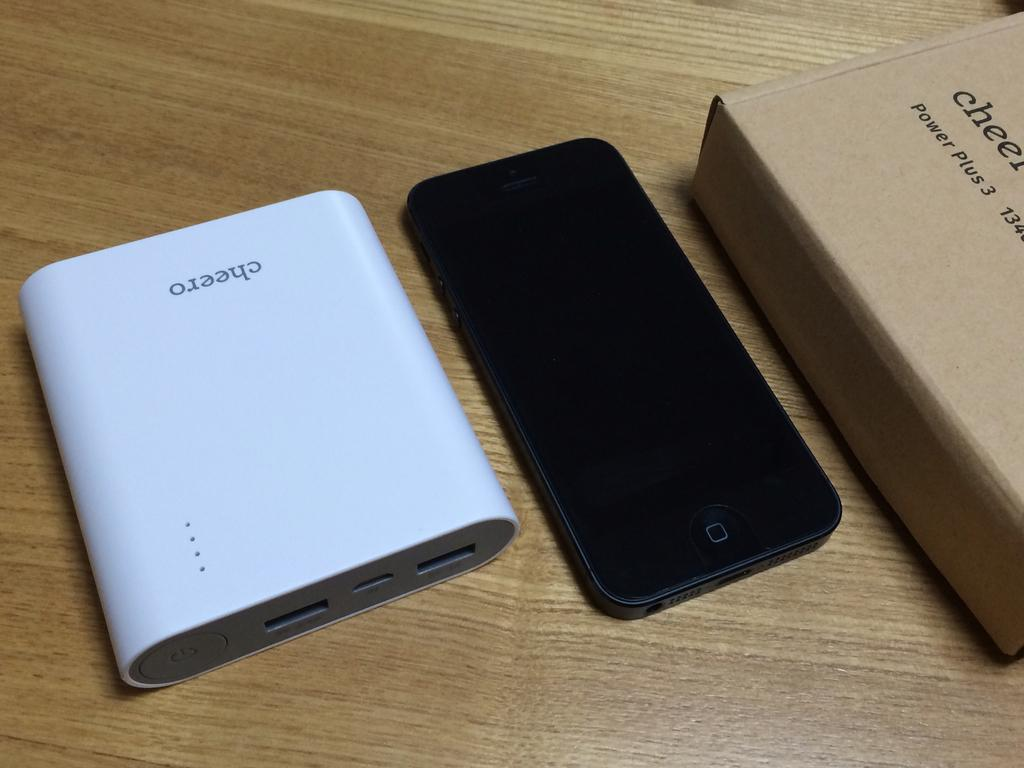Provide a one-sentence caption for the provided image. A phone sits by a device with the word Cheero upside down on it. 